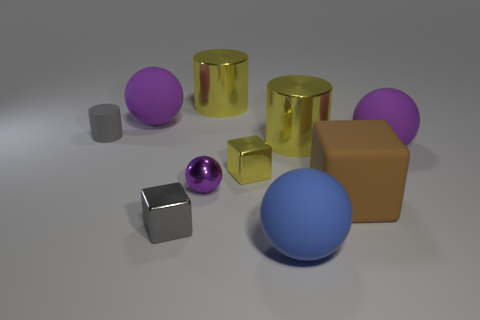Subtract all gray blocks. How many purple spheres are left? 3 Subtract all green balls. Subtract all yellow cubes. How many balls are left? 4 Subtract all blocks. How many objects are left? 7 Subtract all big brown matte cubes. Subtract all large brown rubber objects. How many objects are left? 8 Add 8 big yellow metallic things. How many big yellow metallic things are left? 10 Add 5 purple objects. How many purple objects exist? 8 Subtract 0 gray balls. How many objects are left? 10 